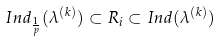<formula> <loc_0><loc_0><loc_500><loc_500>I n d _ { \frac { 1 } { p } } ( \lambda ^ { ( k ) } ) \subset R _ { i } \subset I n d ( \lambda ^ { ( k ) } )</formula> 